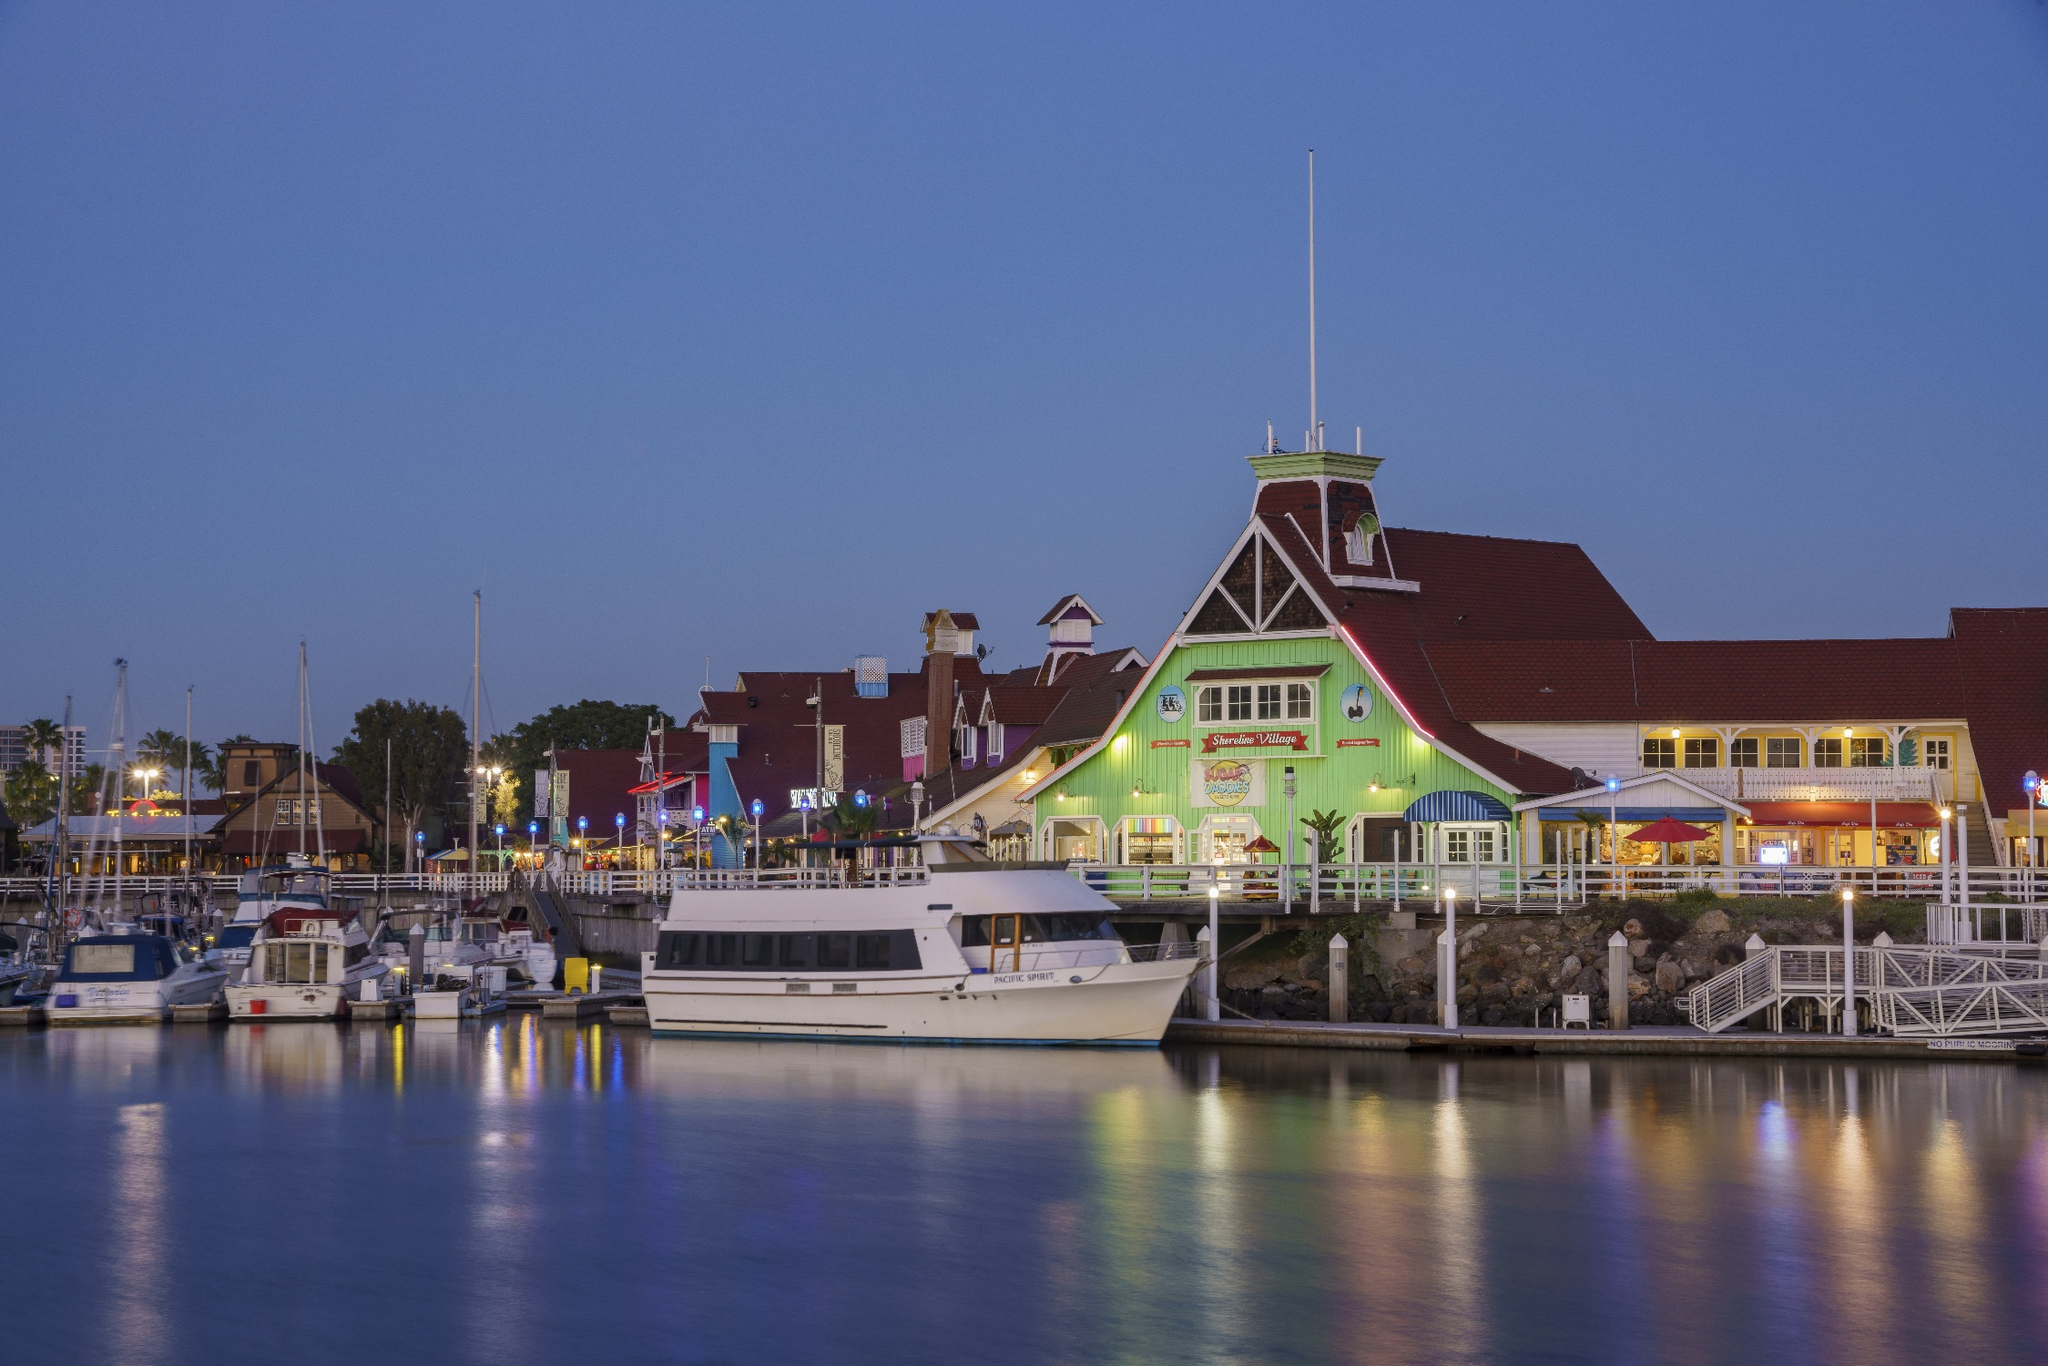What would this scene look like during a festive holiday season? During the festive holiday season, the Long Beach Shoreline Marina transforms into a winter wonderland, filled with cheerful decorations and festive lights. The boats at the docks are adorned with strings of colorful lights and holiday-themed decorations, including wreaths, garlands, and festive ornaments. The shoreline buildings are illuminated with twinkling lights, and charming holiday music fills the air. Parkers' Lighthouse, with its distinctive green exterior, becomes even more prominent, as it dons additional holiday lights and cheerful decorations. Visitors can enjoy holiday-themed activities, such as outdoor ice skating rinks, festive markets selling handcrafted gifts, and special holiday menus at the restaurants. The marina's calm and serene waters reflect the glowing holiday lights, creating a magical and heartwarming atmosphere. It's a perfect setting for families and friends to gather, celebrate, and create lasting holiday memories. Describe a short visit to the marina for someone with only an hour to spare. With only an hour to spare, a visitor at the Long Beach Shoreline Marina can still experience its charm. They could start with a brisk walk along the marina, admiring the beautiful boats and enjoying the fresh sea breeze. A quick stroll would allow them to take in the vibrant colors of the shoreline buildings and the cheerful atmosphere. A visit to Parkers' Lighthouse would be ideal, even if just for a quick drink on their outdoor patio to enjoy the view. The visitor could also stop by a nearby cafe to grab a coffee or pastry to-go. Despite the short visit, the serene and picturesque surroundings will surely leave a lasting impression. 